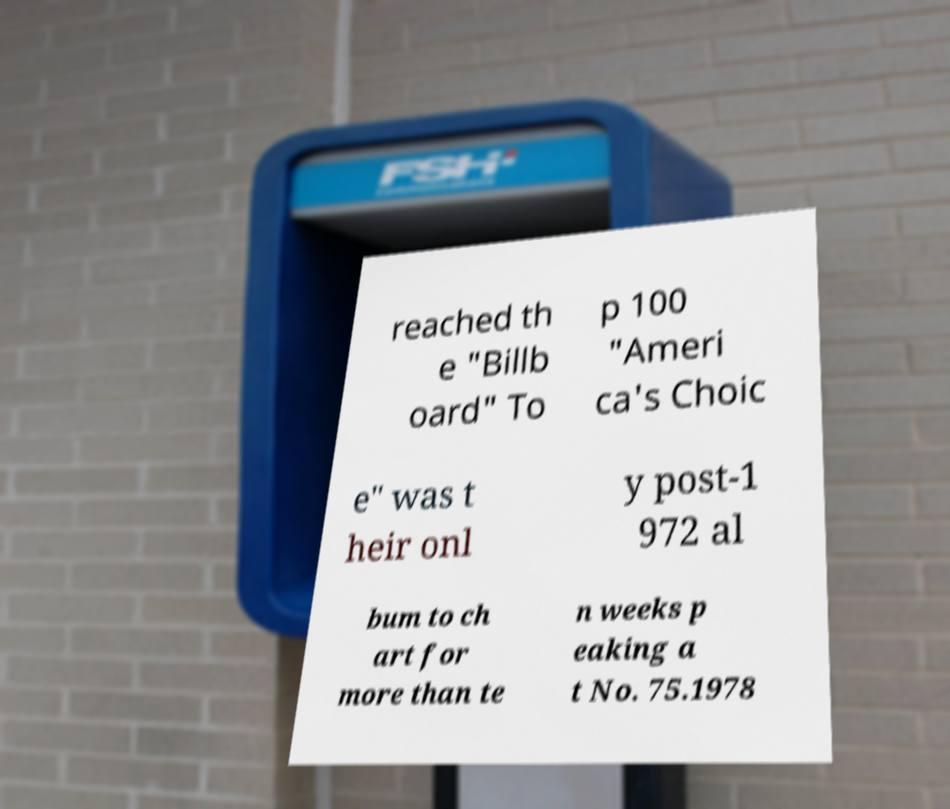Could you extract and type out the text from this image? reached th e "Billb oard" To p 100 "Ameri ca's Choic e" was t heir onl y post-1 972 al bum to ch art for more than te n weeks p eaking a t No. 75.1978 